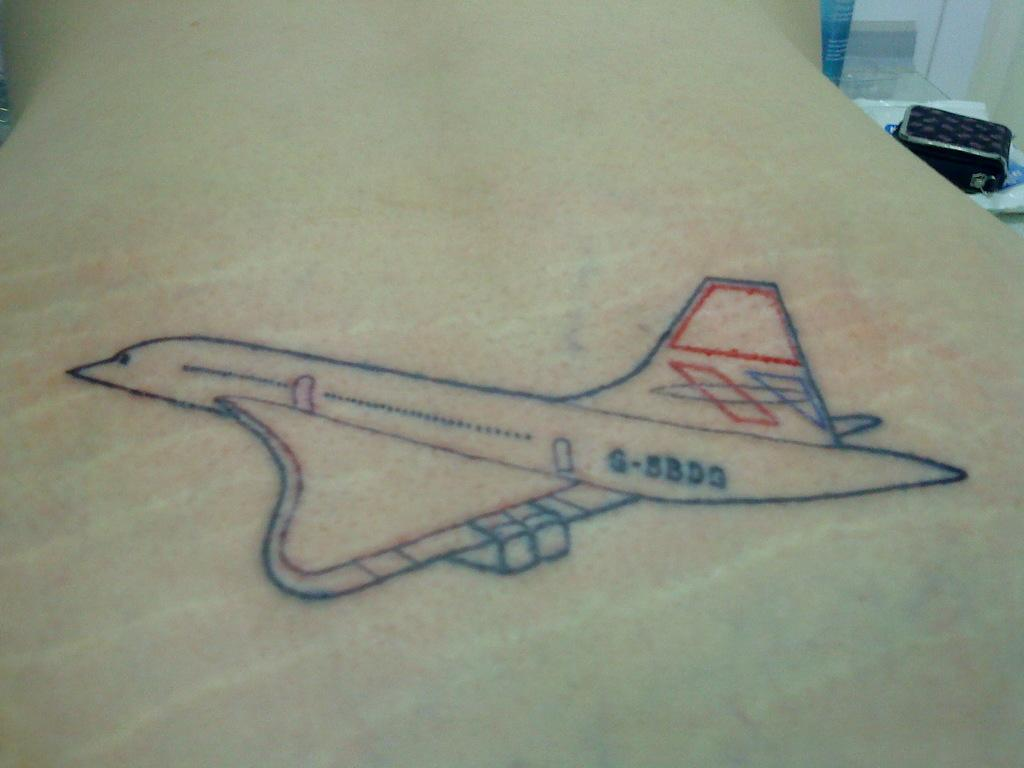<image>
Relay a brief, clear account of the picture shown. a tattoo of a plane that says S-5BDG is in skin 